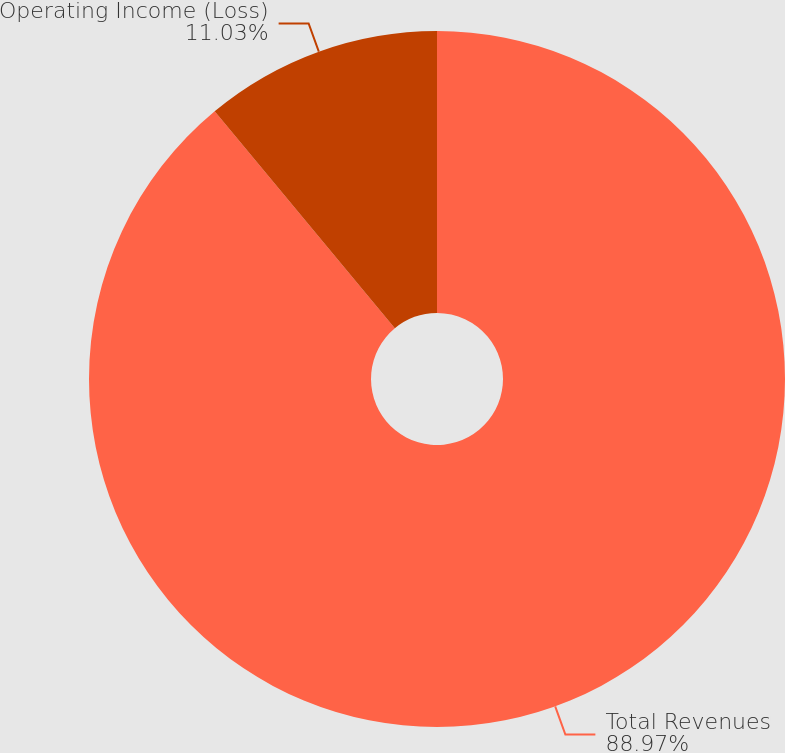Convert chart. <chart><loc_0><loc_0><loc_500><loc_500><pie_chart><fcel>Total Revenues<fcel>Operating Income (Loss)<nl><fcel>88.97%<fcel>11.03%<nl></chart> 